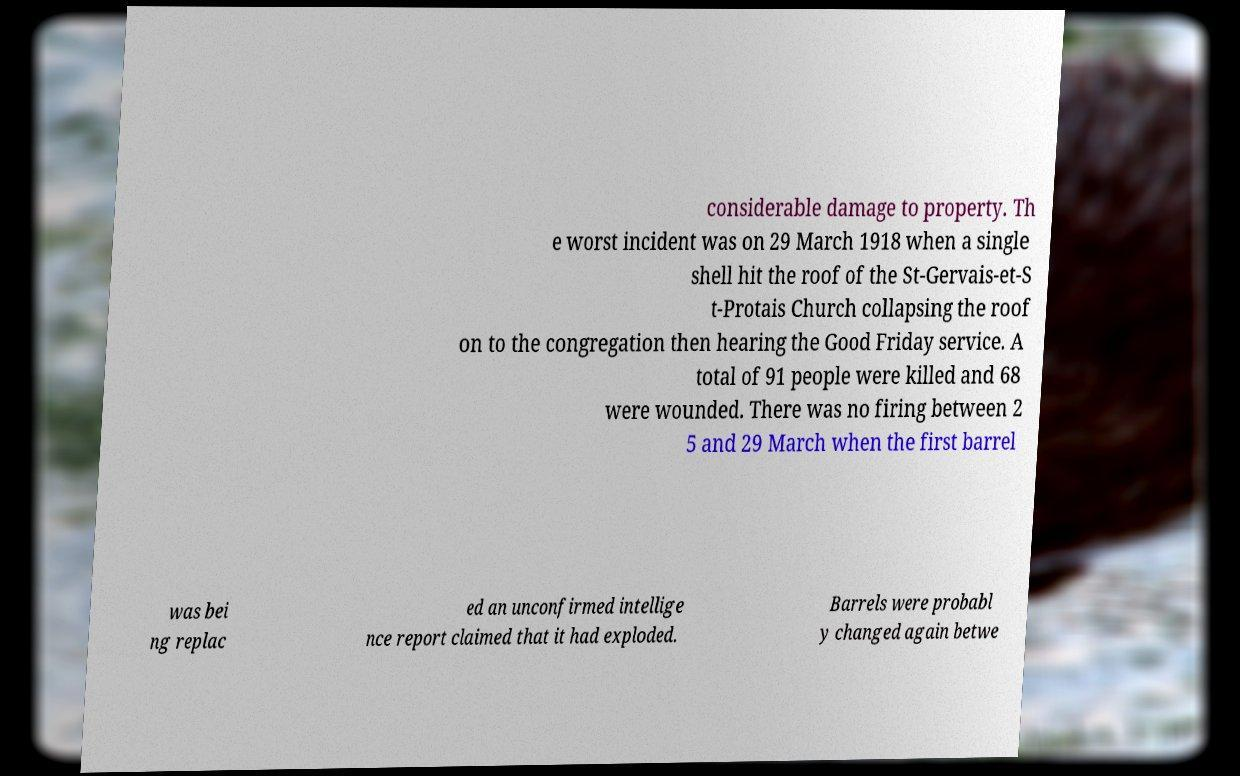There's text embedded in this image that I need extracted. Can you transcribe it verbatim? considerable damage to property. Th e worst incident was on 29 March 1918 when a single shell hit the roof of the St-Gervais-et-S t-Protais Church collapsing the roof on to the congregation then hearing the Good Friday service. A total of 91 people were killed and 68 were wounded. There was no firing between 2 5 and 29 March when the first barrel was bei ng replac ed an unconfirmed intellige nce report claimed that it had exploded. Barrels were probabl y changed again betwe 